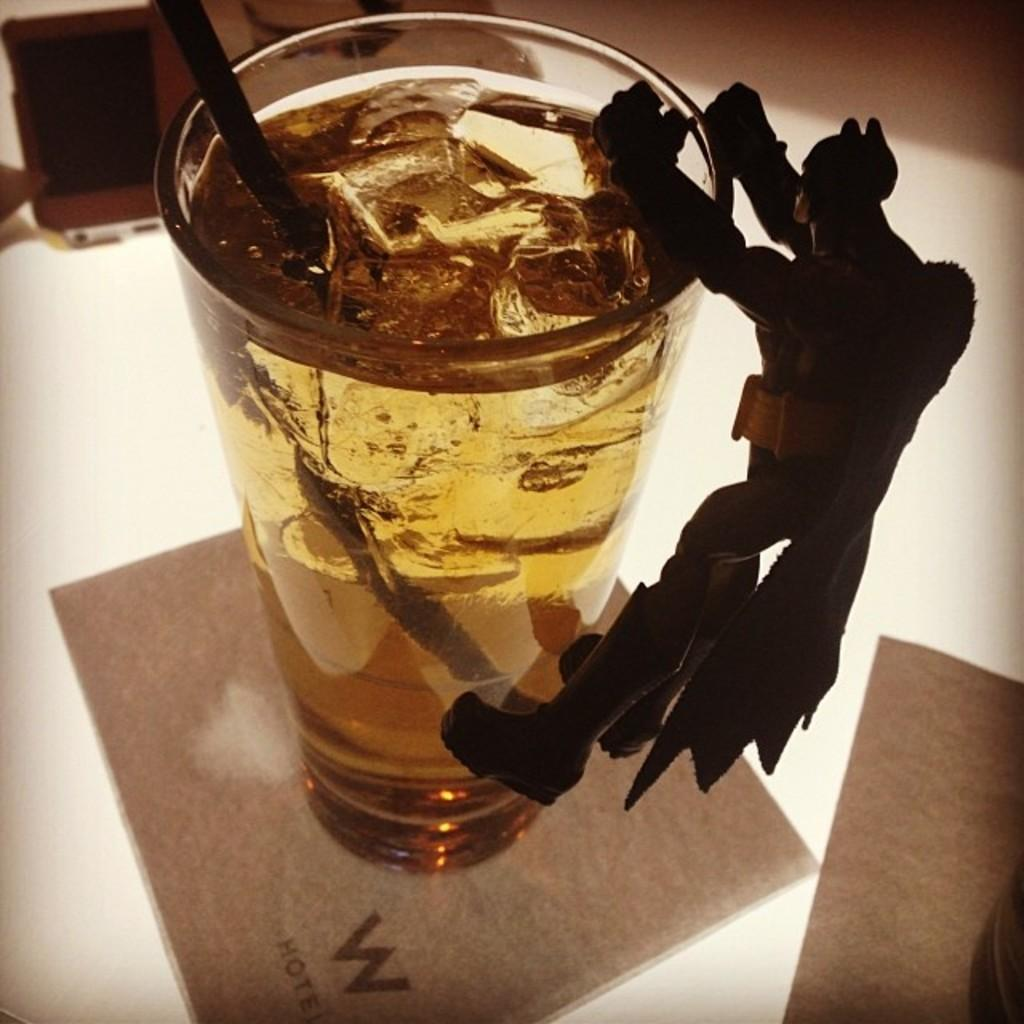What is in the glass that is visible in the image? The glass contains a drink. What can be seen inside the drink in the glass? There are ice cubes in the glass. How might someone consume the drink in the glass? There is a straw in the glass, which can be used for drinking. What type of chocolate is present in the image? There is a chocolate in the shape of a person in the image. What type of disgusting smell is coming from the glass in the image? There is no indication of any smell, let alone a disgusting one, in the image. 